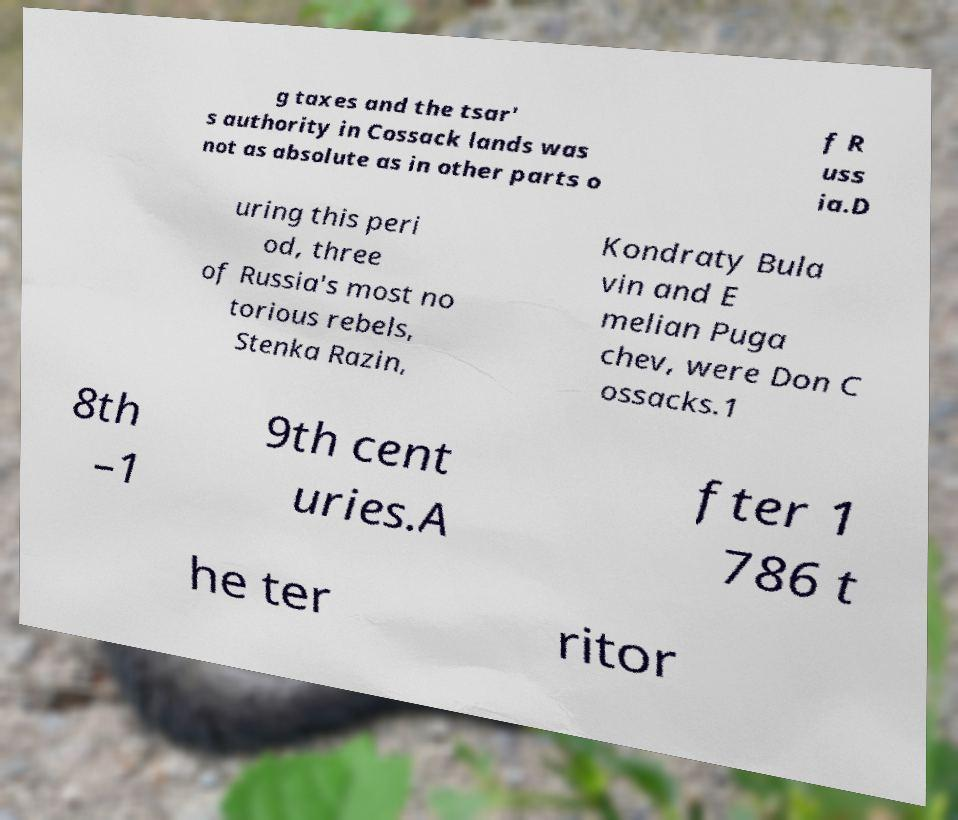There's text embedded in this image that I need extracted. Can you transcribe it verbatim? g taxes and the tsar' s authority in Cossack lands was not as absolute as in other parts o f R uss ia.D uring this peri od, three of Russia's most no torious rebels, Stenka Razin, Kondraty Bula vin and E melian Puga chev, were Don C ossacks.1 8th –1 9th cent uries.A fter 1 786 t he ter ritor 